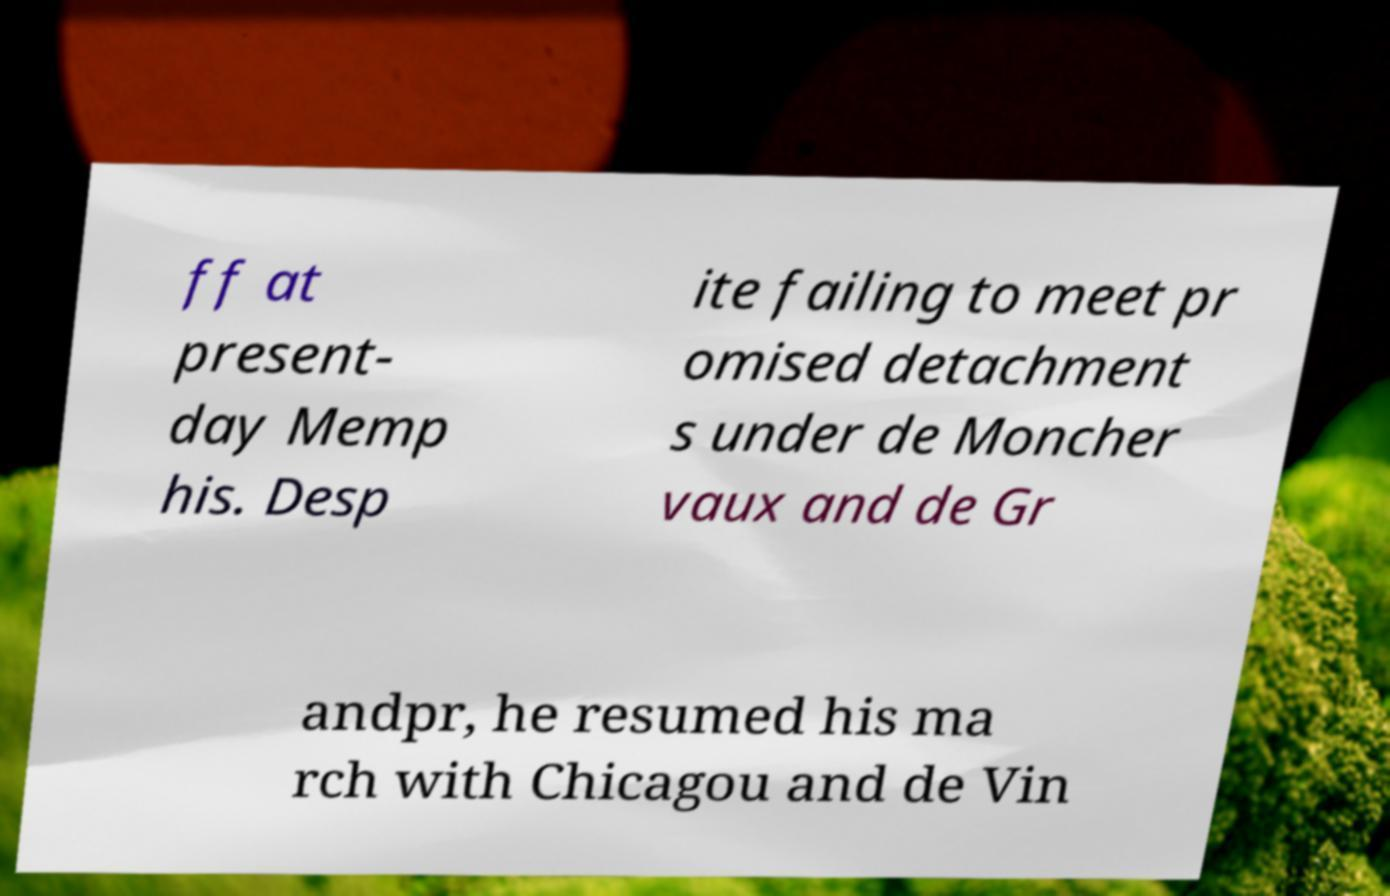I need the written content from this picture converted into text. Can you do that? ff at present- day Memp his. Desp ite failing to meet pr omised detachment s under de Moncher vaux and de Gr andpr, he resumed his ma rch with Chicagou and de Vin 